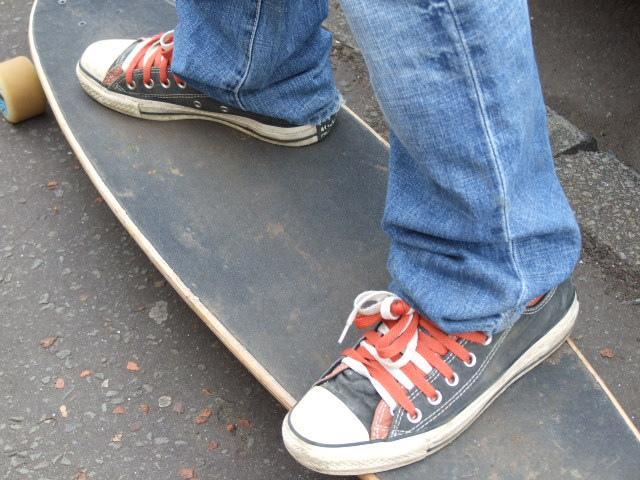What is he standing on?
Quick response, please. Skateboard. What color are these kids shoelaces?
Concise answer only. Orange. What kind of shoes are these?
Short answer required. Converse. What color are the shoelaces?
Write a very short answer. White and red. How many feet are in focus?
Concise answer only. 2. 